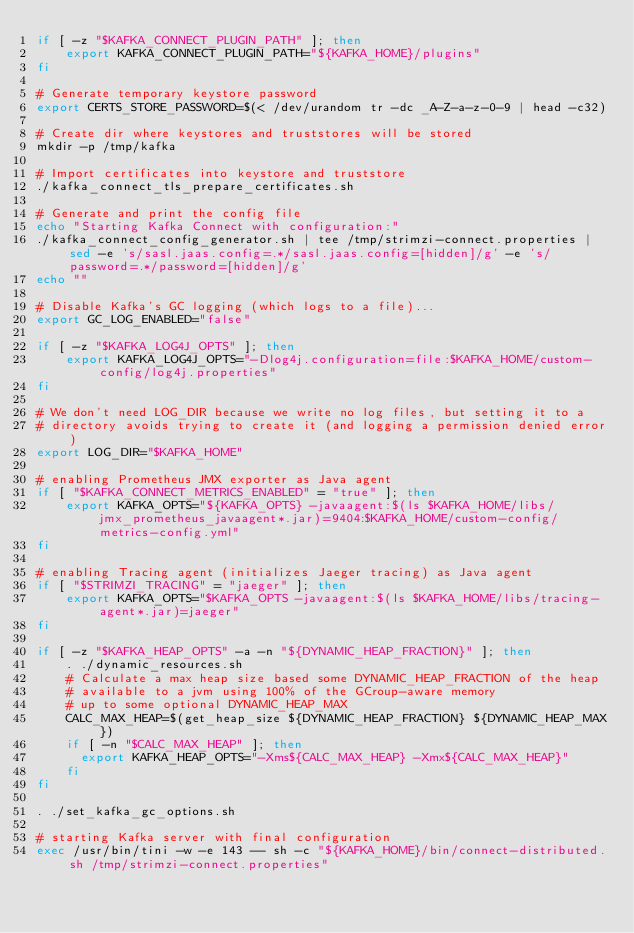<code> <loc_0><loc_0><loc_500><loc_500><_Bash_>if [ -z "$KAFKA_CONNECT_PLUGIN_PATH" ]; then
    export KAFKA_CONNECT_PLUGIN_PATH="${KAFKA_HOME}/plugins"
fi

# Generate temporary keystore password
export CERTS_STORE_PASSWORD=$(< /dev/urandom tr -dc _A-Z-a-z-0-9 | head -c32)

# Create dir where keystores and truststores will be stored
mkdir -p /tmp/kafka

# Import certificates into keystore and truststore
./kafka_connect_tls_prepare_certificates.sh

# Generate and print the config file
echo "Starting Kafka Connect with configuration:"
./kafka_connect_config_generator.sh | tee /tmp/strimzi-connect.properties | sed -e 's/sasl.jaas.config=.*/sasl.jaas.config=[hidden]/g' -e 's/password=.*/password=[hidden]/g'
echo ""

# Disable Kafka's GC logging (which logs to a file)...
export GC_LOG_ENABLED="false"

if [ -z "$KAFKA_LOG4J_OPTS" ]; then
    export KAFKA_LOG4J_OPTS="-Dlog4j.configuration=file:$KAFKA_HOME/custom-config/log4j.properties"
fi

# We don't need LOG_DIR because we write no log files, but setting it to a
# directory avoids trying to create it (and logging a permission denied error)
export LOG_DIR="$KAFKA_HOME"

# enabling Prometheus JMX exporter as Java agent
if [ "$KAFKA_CONNECT_METRICS_ENABLED" = "true" ]; then
    export KAFKA_OPTS="${KAFKA_OPTS} -javaagent:$(ls $KAFKA_HOME/libs/jmx_prometheus_javaagent*.jar)=9404:$KAFKA_HOME/custom-config/metrics-config.yml"
fi

# enabling Tracing agent (initializes Jaeger tracing) as Java agent
if [ "$STRIMZI_TRACING" = "jaeger" ]; then
    export KAFKA_OPTS="$KAFKA_OPTS -javaagent:$(ls $KAFKA_HOME/libs/tracing-agent*.jar)=jaeger"
fi

if [ -z "$KAFKA_HEAP_OPTS" -a -n "${DYNAMIC_HEAP_FRACTION}" ]; then
    . ./dynamic_resources.sh
    # Calculate a max heap size based some DYNAMIC_HEAP_FRACTION of the heap
    # available to a jvm using 100% of the GCroup-aware memory
    # up to some optional DYNAMIC_HEAP_MAX
    CALC_MAX_HEAP=$(get_heap_size ${DYNAMIC_HEAP_FRACTION} ${DYNAMIC_HEAP_MAX})
    if [ -n "$CALC_MAX_HEAP" ]; then
      export KAFKA_HEAP_OPTS="-Xms${CALC_MAX_HEAP} -Xmx${CALC_MAX_HEAP}"
    fi
fi

. ./set_kafka_gc_options.sh

# starting Kafka server with final configuration
exec /usr/bin/tini -w -e 143 -- sh -c "${KAFKA_HOME}/bin/connect-distributed.sh /tmp/strimzi-connect.properties"
</code> 